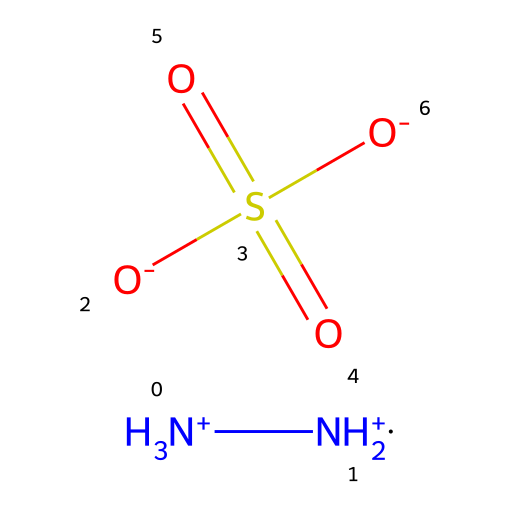What is the primary functional group present in hydrazine sulfate? Hydrazine sulfate contains the hydrazine functional group (two nitrogen atoms connected), as well as a sulfate group (the sulfur and oxygen atoms). The presence of both groups can be identified within the chemical structure.
Answer: hydrazine How many nitrogen atoms are present in hydrazine sulfate? By analyzing the SMILES representation, we can count two nitrogen (N) atoms in the hydrazine portion and see the molecular structure confirms their presence.
Answer: two What is the oxidation state of sulfur in hydrazine sulfate? In the sulfate ion (SO4), sulfur typically has an oxidation state of +6, accounting for the four oxygen atoms each carrying a -2 charge. This is standard for sulfate compounds.
Answer: +6 What type of bonding occurs between the nitrogen atoms in hydrazine sulfate? The bonding between the nitrogen atoms is a single bond as represented in the SMILES notation, showing a direct connection without any indications of multiple bonds.
Answer: single What is the charge of the sulfate ion in the hydrazine sulfate structure? The sulfate ion (SO4) in this context, with two negative charges from the "-O" groups in the SMILES, indicates the overall charge is -2, making it a key feature in this structure.
Answer: -2 Is hydrazine sulfate a potential anticancer agent? Yes, hydrazine sulfate has been investigated for potential anticancer properties, leveraging its unique chemical structure and biological interactions, suggesting its significance in medical research.
Answer: yes 